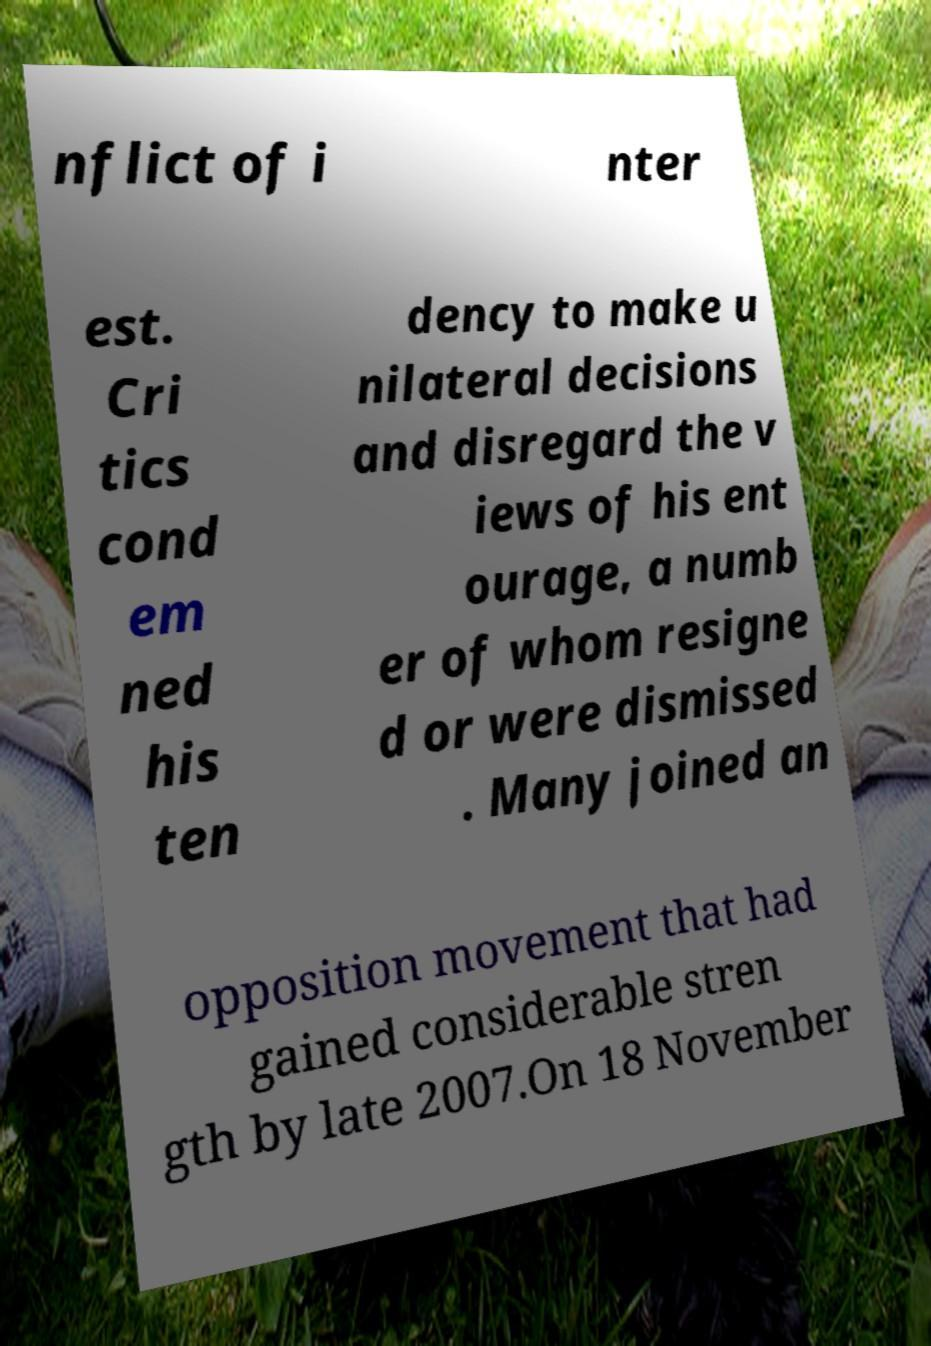Could you extract and type out the text from this image? nflict of i nter est. Cri tics cond em ned his ten dency to make u nilateral decisions and disregard the v iews of his ent ourage, a numb er of whom resigne d or were dismissed . Many joined an opposition movement that had gained considerable stren gth by late 2007.On 18 November 